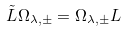Convert formula to latex. <formula><loc_0><loc_0><loc_500><loc_500>\tilde { L } \Omega _ { \lambda , \pm } = \Omega _ { \lambda , \pm } L</formula> 